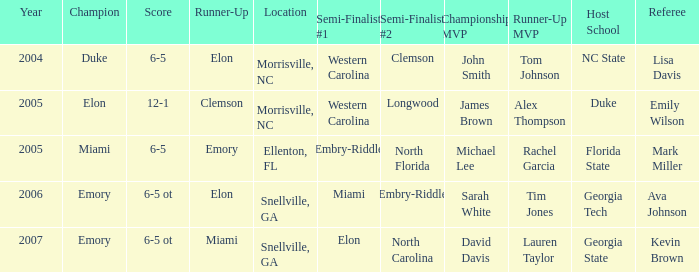When western carolina reached the first semi-finals in 2005, how many teams were recorded as runners-up? 1.0. 